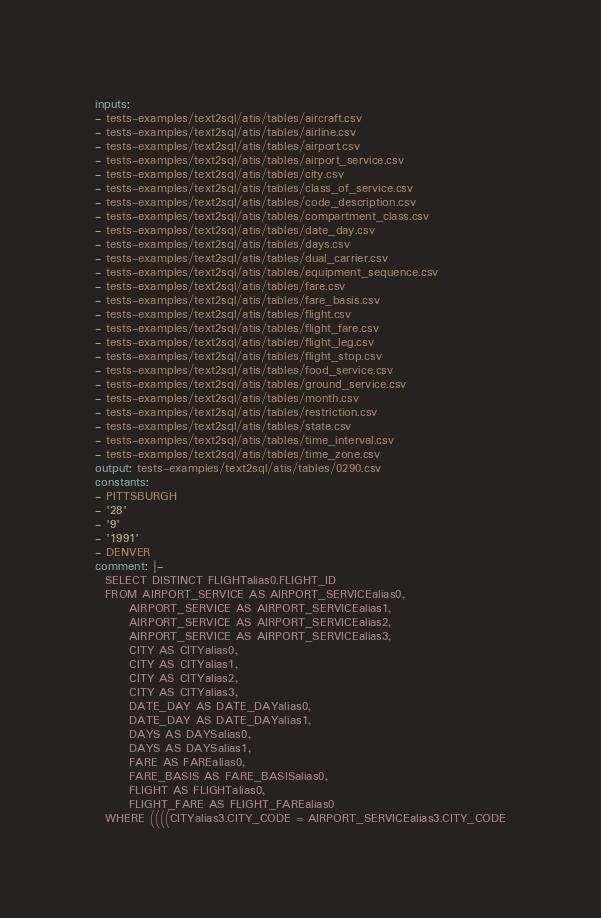<code> <loc_0><loc_0><loc_500><loc_500><_YAML_>inputs:
- tests-examples/text2sql/atis/tables/aircraft.csv
- tests-examples/text2sql/atis/tables/airline.csv
- tests-examples/text2sql/atis/tables/airport.csv
- tests-examples/text2sql/atis/tables/airport_service.csv
- tests-examples/text2sql/atis/tables/city.csv
- tests-examples/text2sql/atis/tables/class_of_service.csv
- tests-examples/text2sql/atis/tables/code_description.csv
- tests-examples/text2sql/atis/tables/compartment_class.csv
- tests-examples/text2sql/atis/tables/date_day.csv
- tests-examples/text2sql/atis/tables/days.csv
- tests-examples/text2sql/atis/tables/dual_carrier.csv
- tests-examples/text2sql/atis/tables/equipment_sequence.csv
- tests-examples/text2sql/atis/tables/fare.csv
- tests-examples/text2sql/atis/tables/fare_basis.csv
- tests-examples/text2sql/atis/tables/flight.csv
- tests-examples/text2sql/atis/tables/flight_fare.csv
- tests-examples/text2sql/atis/tables/flight_leg.csv
- tests-examples/text2sql/atis/tables/flight_stop.csv
- tests-examples/text2sql/atis/tables/food_service.csv
- tests-examples/text2sql/atis/tables/ground_service.csv
- tests-examples/text2sql/atis/tables/month.csv
- tests-examples/text2sql/atis/tables/restriction.csv
- tests-examples/text2sql/atis/tables/state.csv
- tests-examples/text2sql/atis/tables/time_interval.csv
- tests-examples/text2sql/atis/tables/time_zone.csv
output: tests-examples/text2sql/atis/tables/0290.csv
constants:
- PITTSBURGH
- '28'
- '9'
- '1991'
- DENVER
comment: |-
  SELECT DISTINCT FLIGHTalias0.FLIGHT_ID
  FROM AIRPORT_SERVICE AS AIRPORT_SERVICEalias0,
       AIRPORT_SERVICE AS AIRPORT_SERVICEalias1,
       AIRPORT_SERVICE AS AIRPORT_SERVICEalias2,
       AIRPORT_SERVICE AS AIRPORT_SERVICEalias3,
       CITY AS CITYalias0,
       CITY AS CITYalias1,
       CITY AS CITYalias2,
       CITY AS CITYalias3,
       DATE_DAY AS DATE_DAYalias0,
       DATE_DAY AS DATE_DAYalias1,
       DAYS AS DAYSalias0,
       DAYS AS DAYSalias1,
       FARE AS FAREalias0,
       FARE_BASIS AS FARE_BASISalias0,
       FLIGHT AS FLIGHTalias0,
       FLIGHT_FARE AS FLIGHT_FAREalias0
  WHERE ((((CITYalias3.CITY_CODE = AIRPORT_SERVICEalias3.CITY_CODE</code> 